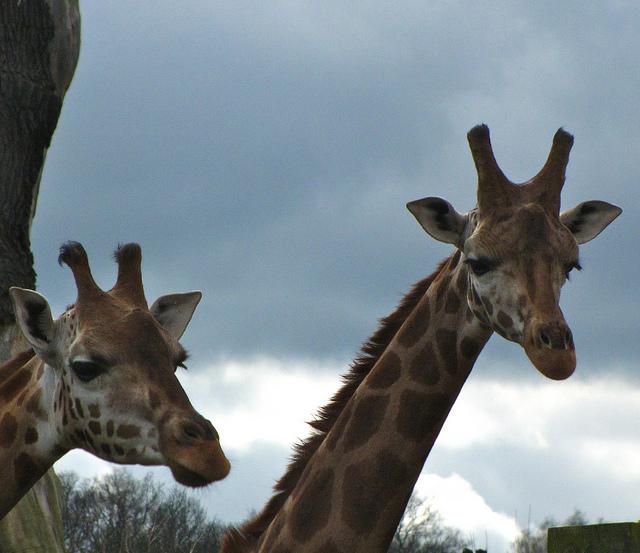What is the condition of the sky?
Keep it brief. Cloudy. What are the things on the top of the giraffe's head?
Keep it brief. Horns. Are the giraffes the same size?
Answer briefly. No. 